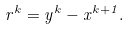Convert formula to latex. <formula><loc_0><loc_0><loc_500><loc_500>r ^ { k } = y ^ { k } - x ^ { k + 1 } .</formula> 